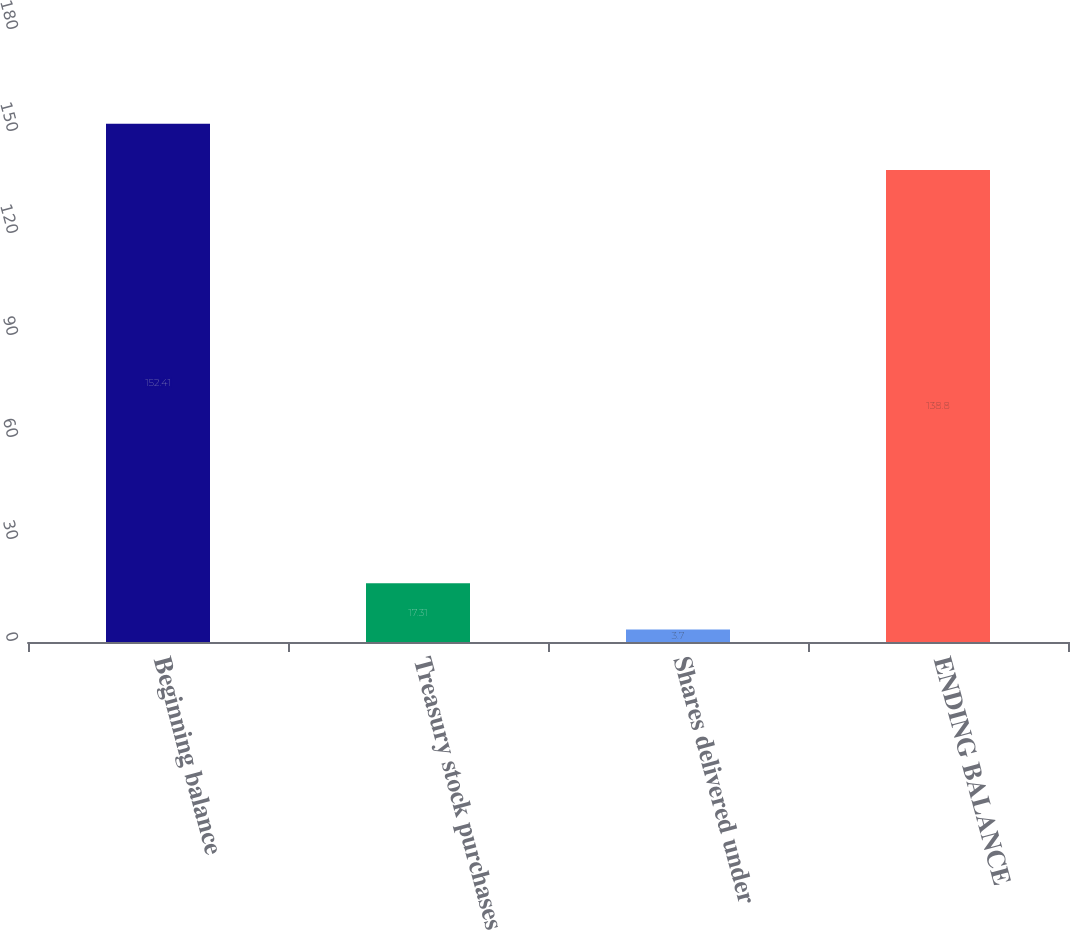Convert chart. <chart><loc_0><loc_0><loc_500><loc_500><bar_chart><fcel>Beginning balance<fcel>Treasury stock purchases<fcel>Shares delivered under<fcel>ENDING BALANCE<nl><fcel>152.41<fcel>17.31<fcel>3.7<fcel>138.8<nl></chart> 